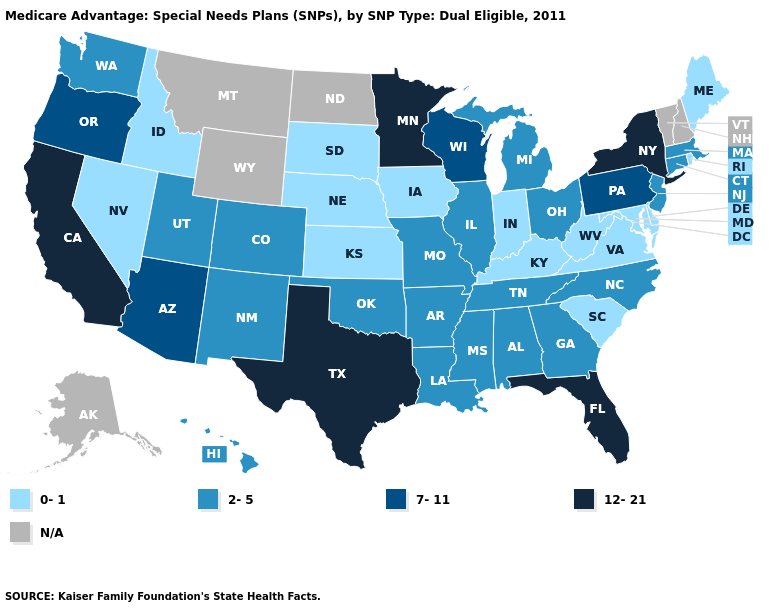What is the highest value in the USA?
Write a very short answer. 12-21. What is the value of Virginia?
Keep it brief. 0-1. What is the lowest value in the South?
Short answer required. 0-1. Which states have the highest value in the USA?
Concise answer only. California, Florida, Minnesota, New York, Texas. Does Arkansas have the highest value in the South?
Answer briefly. No. Name the states that have a value in the range 2-5?
Write a very short answer. Alabama, Arkansas, Colorado, Connecticut, Georgia, Hawaii, Illinois, Louisiana, Massachusetts, Michigan, Missouri, Mississippi, North Carolina, New Jersey, New Mexico, Ohio, Oklahoma, Tennessee, Utah, Washington. Name the states that have a value in the range 0-1?
Answer briefly. Delaware, Iowa, Idaho, Indiana, Kansas, Kentucky, Maryland, Maine, Nebraska, Nevada, Rhode Island, South Carolina, South Dakota, Virginia, West Virginia. Which states have the lowest value in the USA?
Write a very short answer. Delaware, Iowa, Idaho, Indiana, Kansas, Kentucky, Maryland, Maine, Nebraska, Nevada, Rhode Island, South Carolina, South Dakota, Virginia, West Virginia. Name the states that have a value in the range 12-21?
Short answer required. California, Florida, Minnesota, New York, Texas. Which states hav the highest value in the MidWest?
Write a very short answer. Minnesota. Which states have the highest value in the USA?
Give a very brief answer. California, Florida, Minnesota, New York, Texas. Name the states that have a value in the range 2-5?
Concise answer only. Alabama, Arkansas, Colorado, Connecticut, Georgia, Hawaii, Illinois, Louisiana, Massachusetts, Michigan, Missouri, Mississippi, North Carolina, New Jersey, New Mexico, Ohio, Oklahoma, Tennessee, Utah, Washington. Name the states that have a value in the range 0-1?
Keep it brief. Delaware, Iowa, Idaho, Indiana, Kansas, Kentucky, Maryland, Maine, Nebraska, Nevada, Rhode Island, South Carolina, South Dakota, Virginia, West Virginia. 